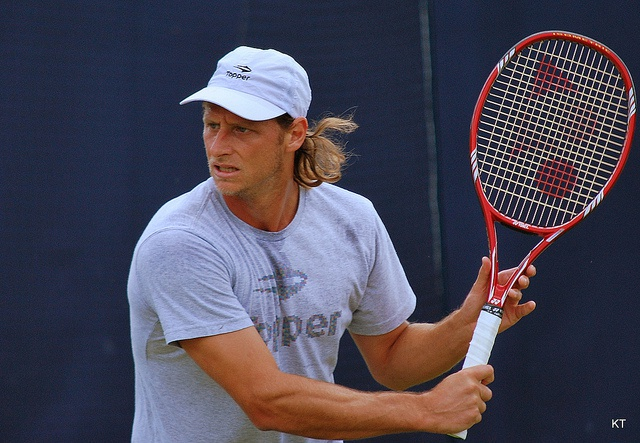Describe the objects in this image and their specific colors. I can see people in navy, darkgray, brown, salmon, and gray tones and tennis racket in navy, black, lightgray, and darkgray tones in this image. 